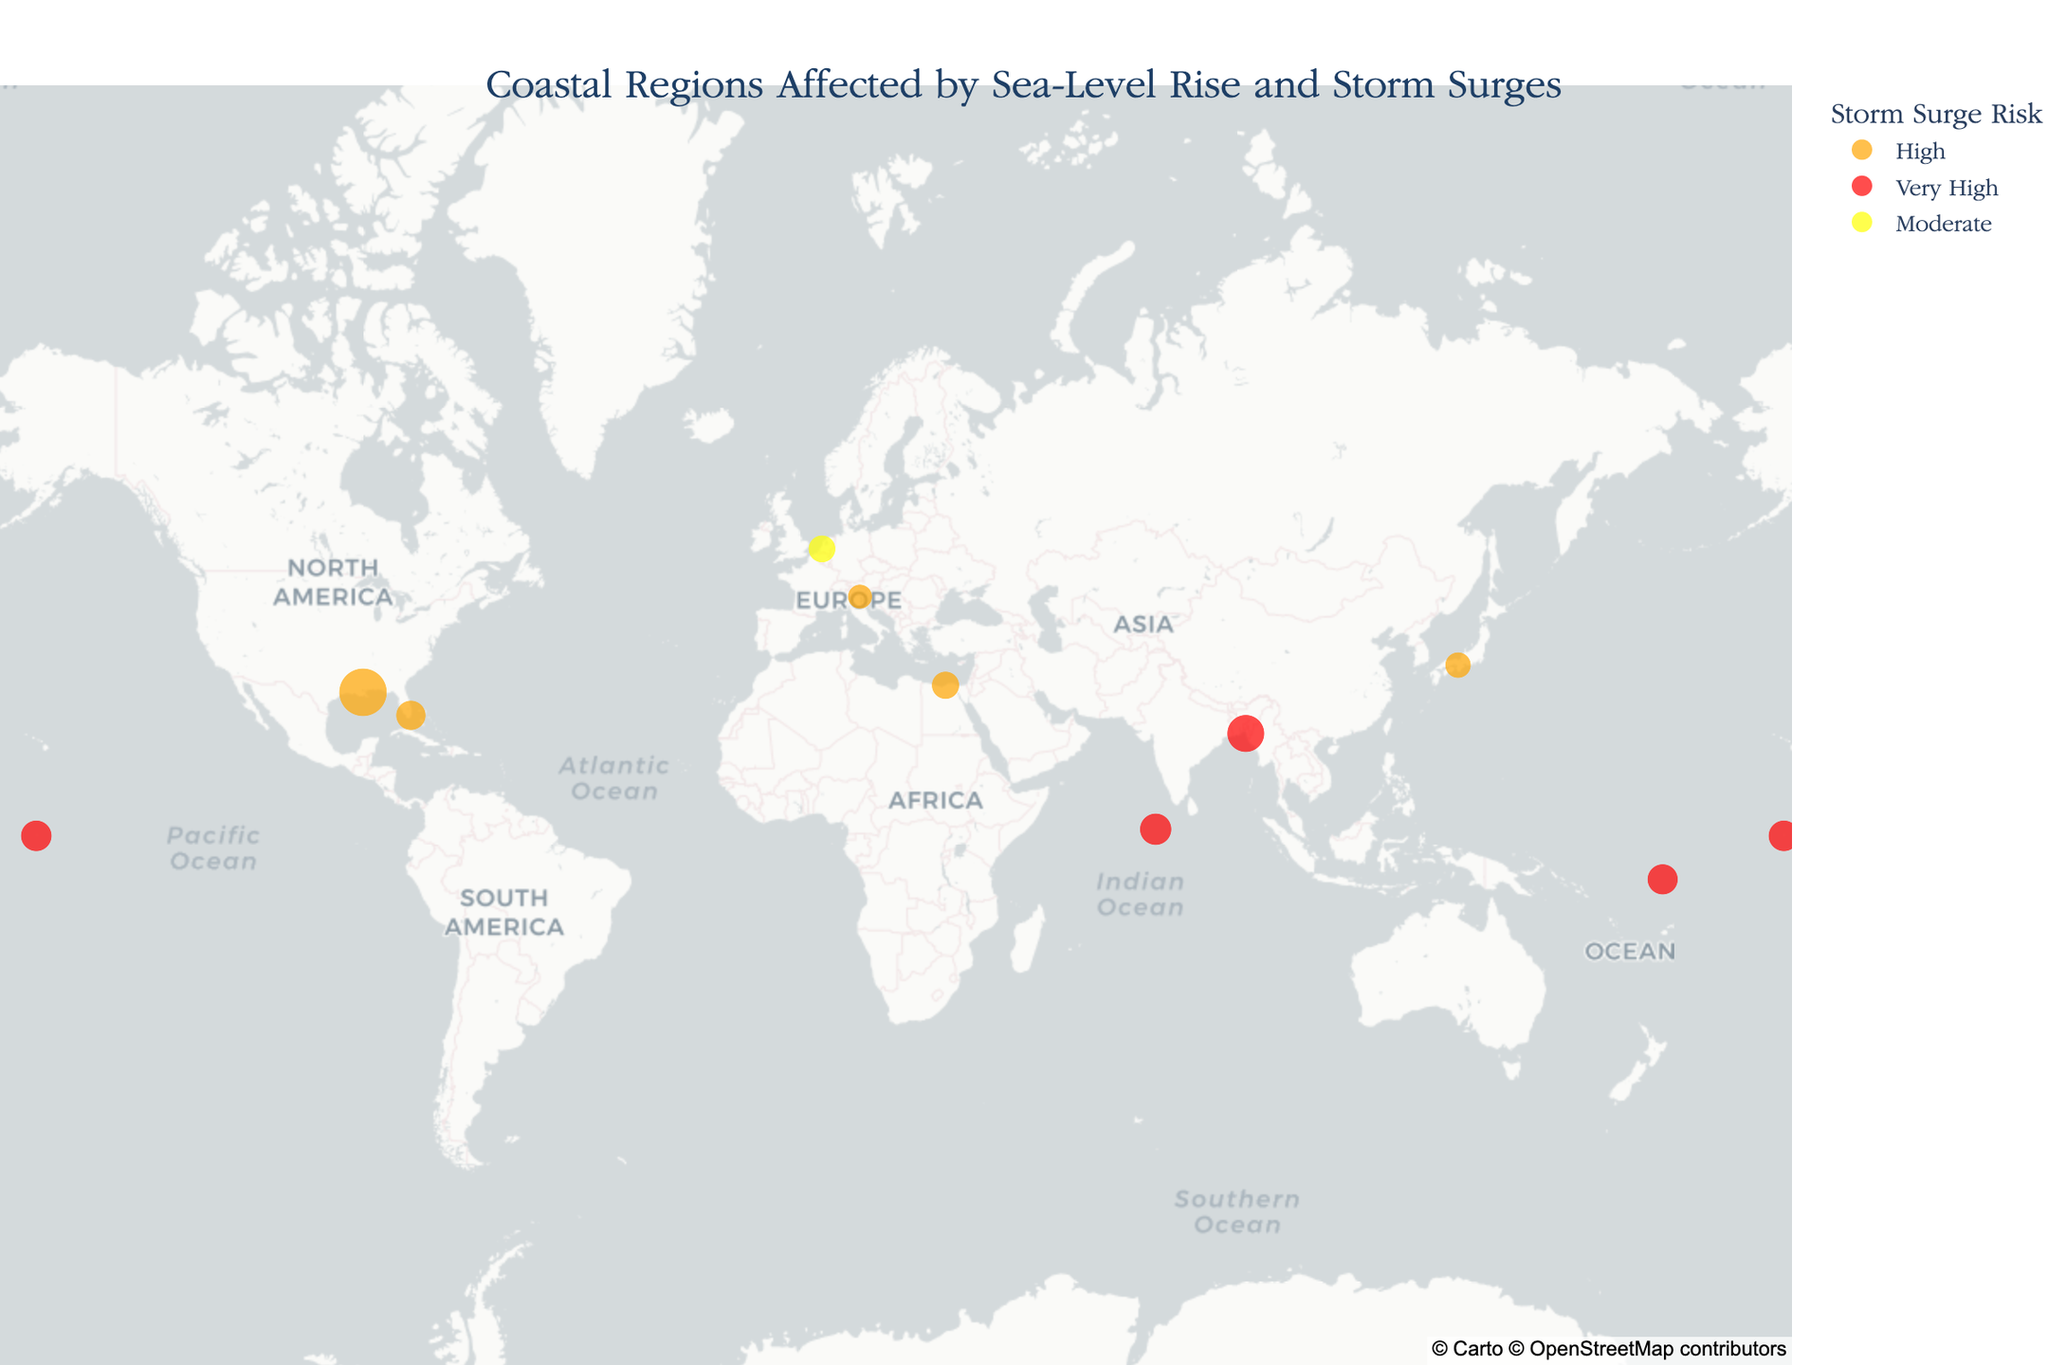What is the title of the figure? The title is identified at the top center of the figure, usually in a larger font and bold to stand out.
Answer: "Coastal Regions Affected by Sea-Level Rise and Storm Surges" How are regions with "Very High" storm surge risk identified on the map? The color legend indicates that regions with a "Very High" storm surge risk are marked in red.
Answer: By the red color Which region experiences the highest sea-level rise per year? The figure includes a map with points of different sizes, representing sea-level rise in millimeters per year. The largest sized point indicates the highest sea-level rise.
Answer: New Orleans What is the storm surge risk level for Rotterdam? By inspecting the map and looking for Rotterdam, then referencing its color per the legend.
Answer: Moderate How many regions have a "High" storm surge risk? Count the number of orange-colored points, as per the legend and map's visual representation.
Answer: Four What is the average sea-level rise for regions with "Very High" storm surge risk? Identify regions with "Very High" risk (red-colored) and average their sea-level rise values: Maldives (4.2), Bangladesh Coast (5.8), Tuvalu (3.9), Kiribati (4.0). The calculation is (4.2 + 5.8 + 3.9 + 4.0) / 4.
Answer: 4.475 mm/year Which regions are located in the Northern Hemisphere? Examine the latitude values greater than 0° and identify corresponding regions on the map.
Answer: New Orleans, Venice, Miami, Bangladesh Coast, Rotterdam, Alexandria, Osaka Is Venice facing a greater sea-level rise or storm surge risk, comparatively? Check Venice's sea-level rise value and storm surge risk color on the legend. Venice is marked with 2.5 mm/year and a high-risk color.
Answer: Greater storm surge risk What literary inspiration is linked with the Maldives? Hover over the corresponding point for Maldives, where hover data reveals the literary inspiration.
Answer: "The Island by Victoria Hislop" Which region is closer to the equator, Maldives or Kiribati? Compare the absolute latitude values of Maldives (3.2028) and Kiribati (1.8369), the closer value indicates proximity.
Answer: Kiribati 